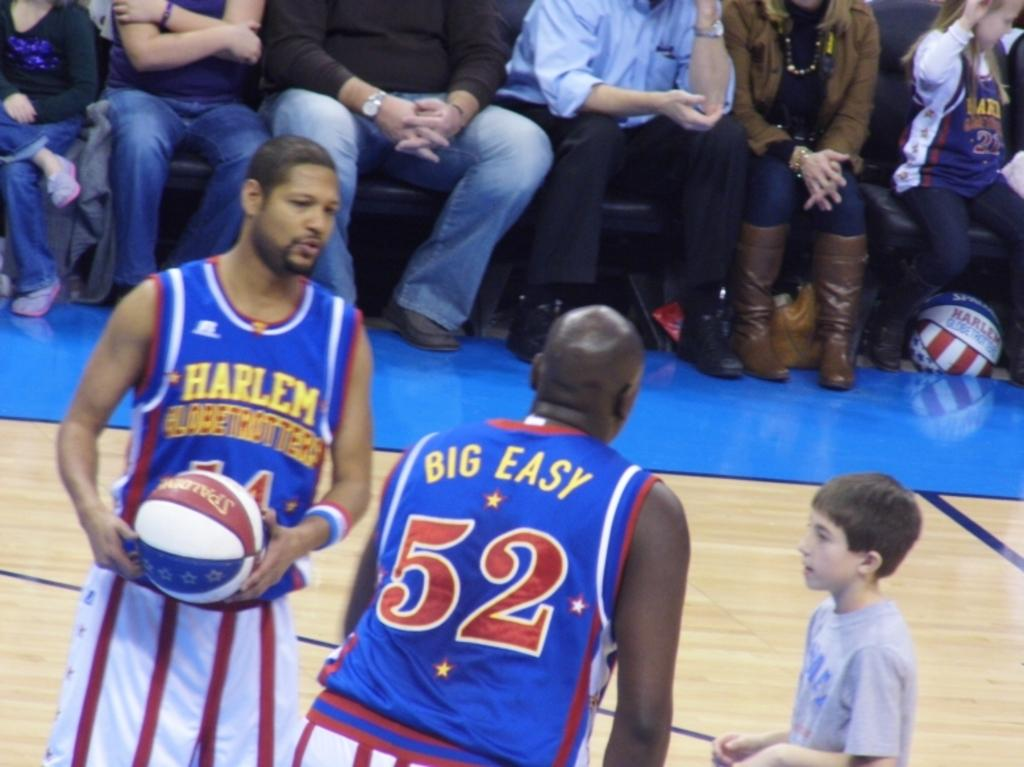<image>
Offer a succinct explanation of the picture presented. Basketball players for Harlem named Big Easy helping a child with the ball. 